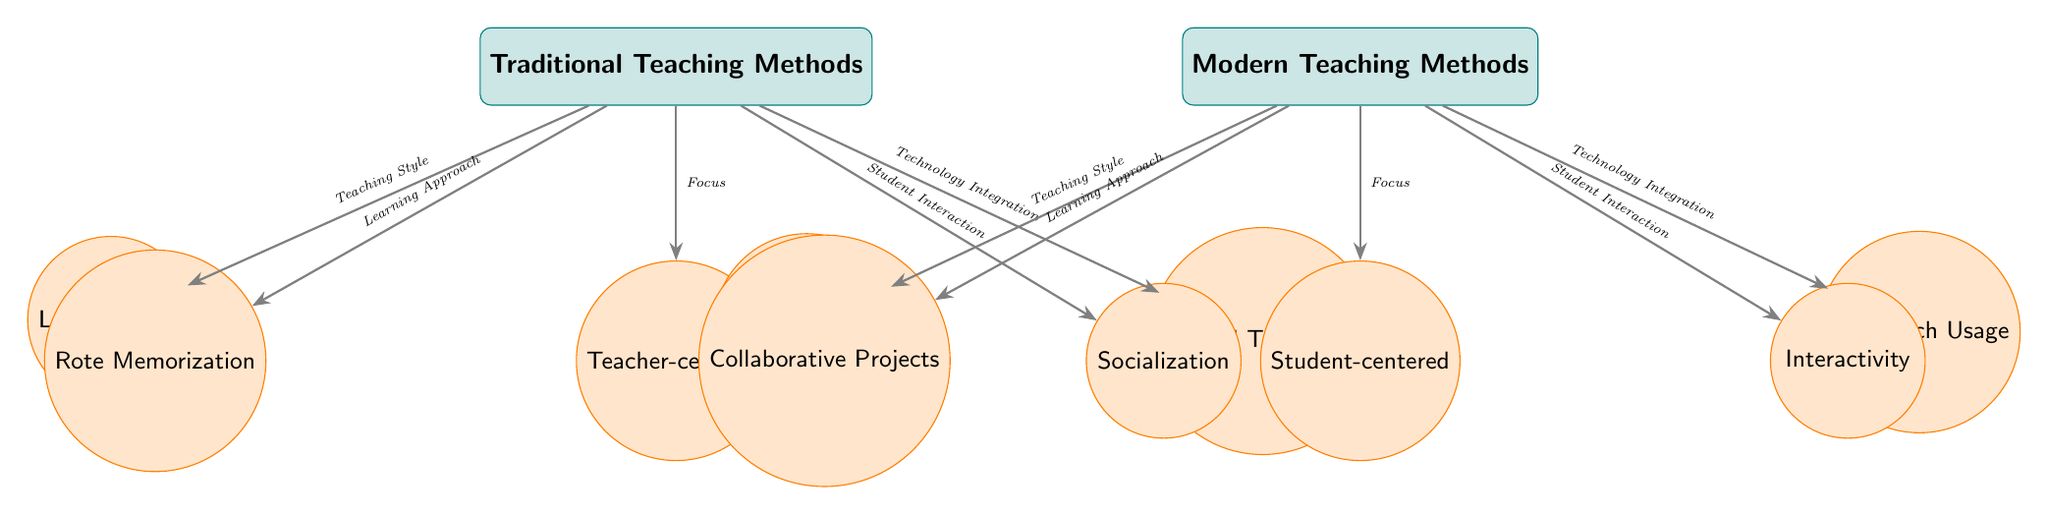What are the two main categories of teaching methods in the diagram? The diagram clearly illustrates two main teaching methods at the top: 'Traditional Teaching Methods' on the left and 'Modern Teaching Methods' on the right.
Answer: Traditional Teaching Methods, Modern Teaching Methods How many sub-nodes are associated with Traditional Teaching Methods? Under 'Traditional Teaching Methods', there are five sub-nodes branching out: 'Lecture-based', 'Teacher-centered', 'Limited Technology', 'Rote Memorization', and 'Socialization'. Thus, the count of sub-nodes is five.
Answer: 5 Which teaching method focuses on student-centered learning? Upon examining the nodes under 'Modern Teaching Methods', the sub-node 'Student-centered' directly corresponds to this concept, indicating that the focus is indeed on student-centered learning in modern methods.
Answer: Student-centered What is the relationship between the 'Teaching Style' of Traditional and Modern methods? Both teaching styles are linked to their respective main categories: 'Lecture-based' for Traditional Teaching Methods and 'Active Learning' for Modern Teaching Methods, denoting a fundamental contrast in approach, where one is passive and the other is participatory.
Answer: Different Which sub-node has the greatest technology integration according to the diagram? In the diagram, 'High Tech Usage' is clearly marked as a sub-node under 'Modern Teaching Methods', signifying that it represents the most significant integration of technology in comparison to the 'Limited Technology' of the traditional approach.
Answer: High Tech Usage How does 'Socialization' differ from 'Interactivity' in the context of the teaching methods? 'Socialization' is noted under 'Traditional Teaching Methods', focusing on peer interaction but often in a less dynamic format, while 'Interactivity' is listed under 'Modern Teaching Methods', which emphasizes engagement and active participation among students, highlighting a shift towards more dynamic forms of interaction.
Answer: Different What does the sub-node 'Collaborative Projects' imply about modern teaching approaches? 'Collaborative Projects' suggests that modern teaching methods emphasize teamwork and joint effort among students, which contrasts sharply with the individual-centric approaches generally found in traditional methods.
Answer: Teamwork What teaching style is associated with 'Lecture-based'? The sub-node 'Lecture-based' is directly connected to 'Teaching Style' under 'Traditional Teaching Methods', indicating that it represents a key approach in this category of teaching.
Answer: Lecture-based 